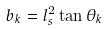<formula> <loc_0><loc_0><loc_500><loc_500>b _ { k } = l _ { s } ^ { 2 } \tan \theta _ { k }</formula> 